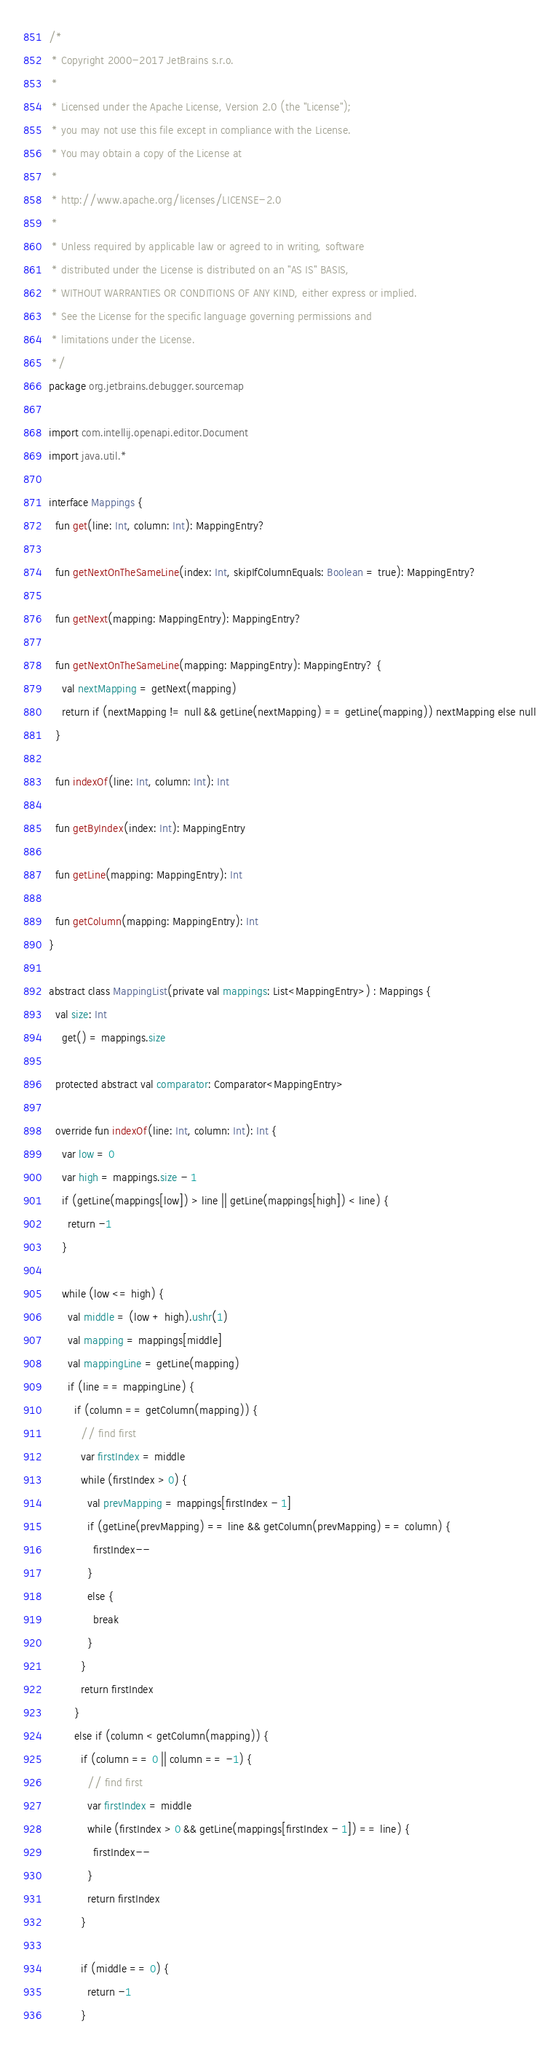Convert code to text. <code><loc_0><loc_0><loc_500><loc_500><_Kotlin_>/*
 * Copyright 2000-2017 JetBrains s.r.o.
 *
 * Licensed under the Apache License, Version 2.0 (the "License");
 * you may not use this file except in compliance with the License.
 * You may obtain a copy of the License at
 *
 * http://www.apache.org/licenses/LICENSE-2.0
 *
 * Unless required by applicable law or agreed to in writing, software
 * distributed under the License is distributed on an "AS IS" BASIS,
 * WITHOUT WARRANTIES OR CONDITIONS OF ANY KIND, either express or implied.
 * See the License for the specific language governing permissions and
 * limitations under the License.
 */
package org.jetbrains.debugger.sourcemap

import com.intellij.openapi.editor.Document
import java.util.*

interface Mappings {
  fun get(line: Int, column: Int): MappingEntry?

  fun getNextOnTheSameLine(index: Int, skipIfColumnEquals: Boolean = true): MappingEntry?

  fun getNext(mapping: MappingEntry): MappingEntry?

  fun getNextOnTheSameLine(mapping: MappingEntry): MappingEntry? {
    val nextMapping = getNext(mapping)
    return if (nextMapping != null && getLine(nextMapping) == getLine(mapping)) nextMapping else null
  }

  fun indexOf(line: Int, column: Int): Int

  fun getByIndex(index: Int): MappingEntry

  fun getLine(mapping: MappingEntry): Int

  fun getColumn(mapping: MappingEntry): Int
}

abstract class MappingList(private val mappings: List<MappingEntry>) : Mappings {
  val size: Int
    get() = mappings.size

  protected abstract val comparator: Comparator<MappingEntry>

  override fun indexOf(line: Int, column: Int): Int {
    var low = 0
    var high = mappings.size - 1
    if (getLine(mappings[low]) > line || getLine(mappings[high]) < line) {
      return -1
    }

    while (low <= high) {
      val middle = (low + high).ushr(1)
      val mapping = mappings[middle]
      val mappingLine = getLine(mapping)
      if (line == mappingLine) {
        if (column == getColumn(mapping)) {
          // find first
          var firstIndex = middle
          while (firstIndex > 0) {
            val prevMapping = mappings[firstIndex - 1]
            if (getLine(prevMapping) == line && getColumn(prevMapping) == column) {
              firstIndex--
            }
            else {
              break
            }
          }
          return firstIndex
        }
        else if (column < getColumn(mapping)) {
          if (column == 0 || column == -1) {
            // find first
            var firstIndex = middle
            while (firstIndex > 0 && getLine(mappings[firstIndex - 1]) == line) {
              firstIndex--
            }
            return firstIndex
          }

          if (middle == 0) {
            return -1
          }
</code> 